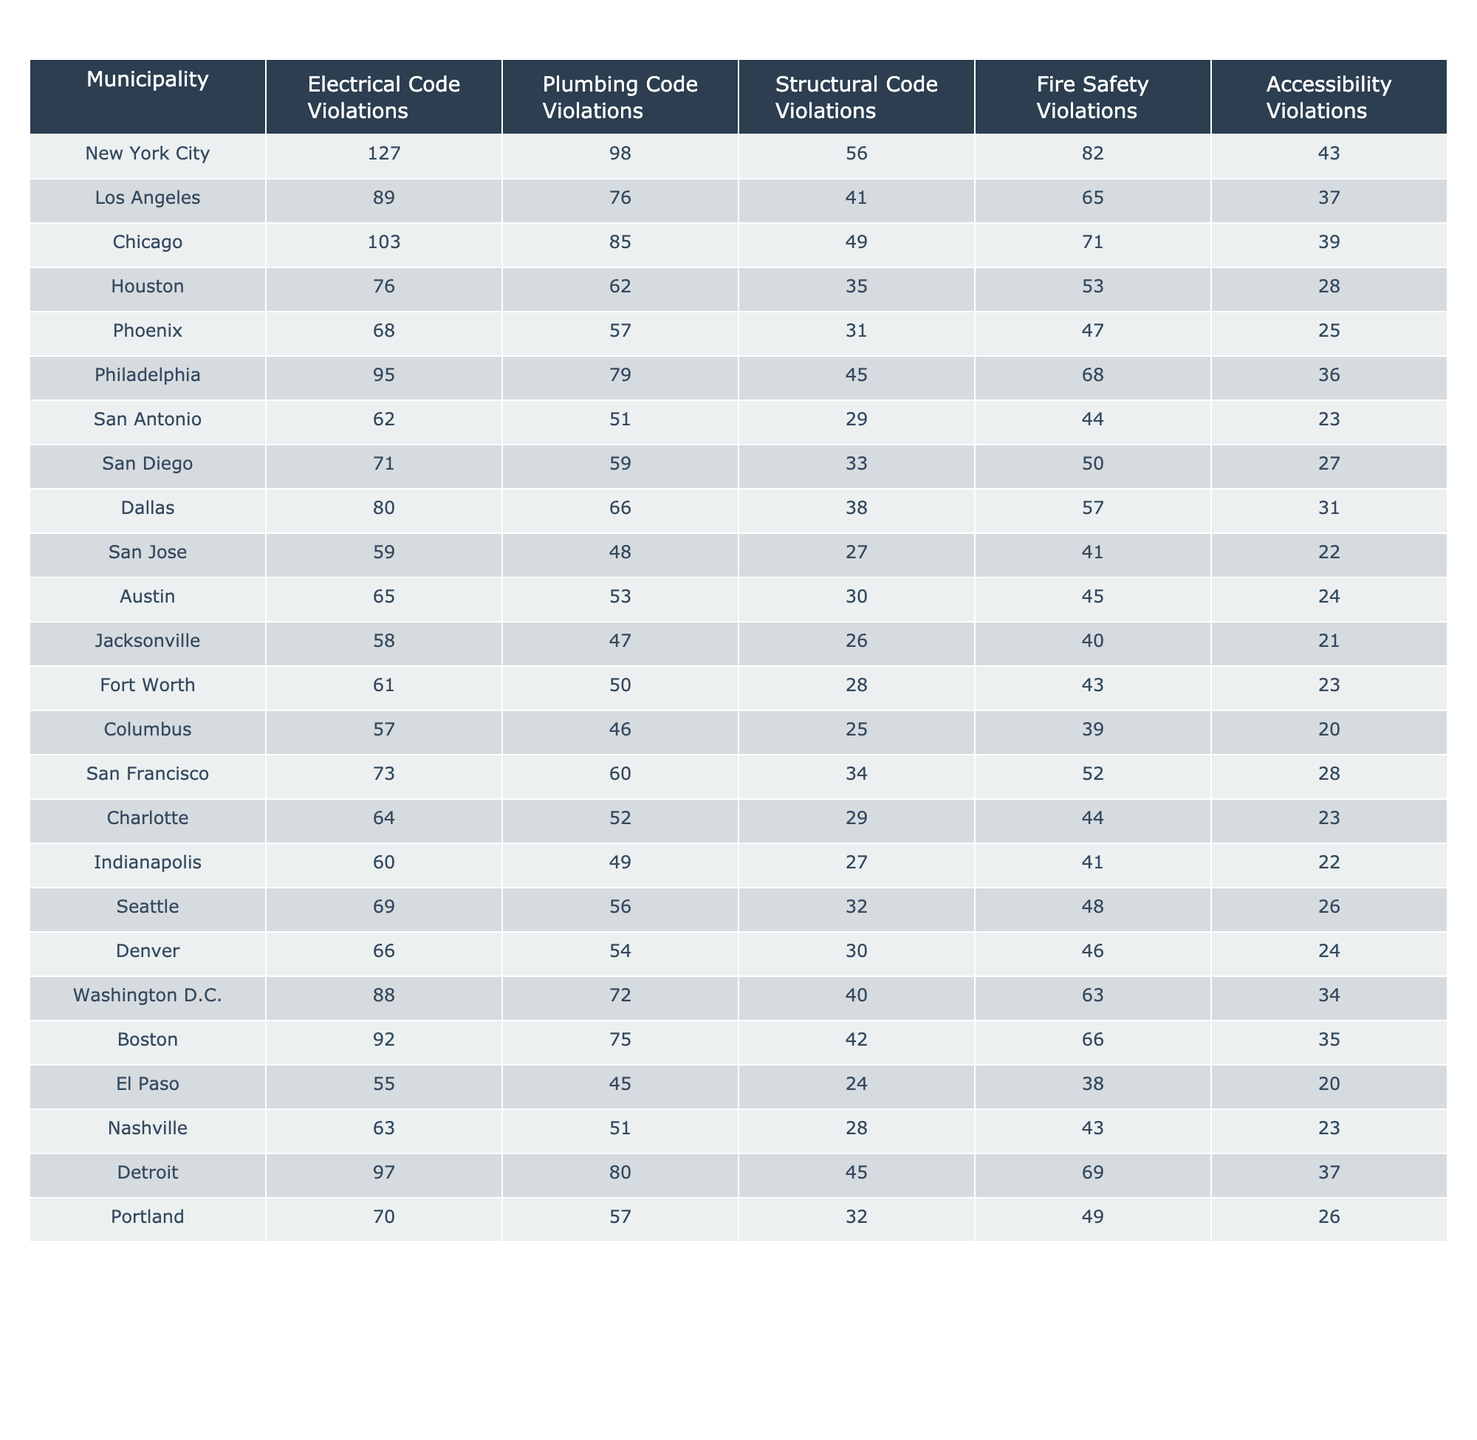What municipality has the highest number of Electrical Code Violations? By looking at the first column in the table, New York City has 127 Electrical Code Violations, which is higher than any other municipality listed.
Answer: New York City What is the total number of Structural Code Violations across all municipalities? To find the total, I sum the Structural Code Violations: 56 + 41 + 49 + 35 + 31 + 45 + 29 + 33 + 38 + 27 + 30 + 26 + 28 + 25 + 34 + 29 + 27 + 32 + 30 + 40 + 42 + 24 + 28 + 45 + 32 = 694.
Answer: 694 Which municipality has the least number of Plumbing Code Violations? San Antonio has the least number of Plumbing Code Violations, with a total of 51. This can be determined by comparing the values in the Plumbing Code Violations column and finding the lowest.
Answer: San Antonio Are there more Electrical Code Violations in Chicago than in Houston? Chicago has 103 Electrical Code Violations while Houston has 76. Therefore, Chicago has more violations than Houston.
Answer: Yes What is the average number of Fire Safety Violations across all municipalities? To calculate the average, I sum all Fire Safety Violations (82 + 65 + 71 + 53 + 47 + 68 + 44 + 50 + 57 + 41 + 45 + 40 + 43 + 39 + 52 + 44 + 41 + 48 + 46 + 63 + 66 + 38 + 43 + 69 + 49 = 998) and divide by the number of municipalities (25). So the average is 998 / 25 = 39.92.
Answer: 39.92 Which municipalities have more than 80 Accessibility Violations? A review of the Accessibility Violations column shows that New York City (43), Chicago (39), Philadelphia (36), and the rest have fewer than or equal to 36 violations, meaning no municipalities have more than 80 Accessibility Violations.
Answer: None What is the difference in the number of Plumbing Code Violations between Los Angeles and Philadelphia? Los Angeles has 76 Plumbing Code Violations while Philadelphia has 79. The difference is calculated by subtracting Los Angeles' violations from Philadelphia's (79 - 76 = 3).
Answer: 3 Is the number of Fire Safety Violations in Dallas greater than the average of all municipalities? The average Fire Safety Violations across all municipalities is calculated to be 39.92, while Dallas has 57 Fire Safety Violations. Since 57 is greater than 39.92, the answer is yes.
Answer: Yes How many municipalities have more Fire Safety Violations than Structural Code Violations? By comparing each municipality's Fire Safety and Structural Code Violations, I find that the following have more Fire Safety Violations than Structural Code Violations: New York City, Chicago, Philadelphia, Dallas, San Francisco, and Washington D.C. This totals 6 municipalities.
Answer: 6 Which municipality has the least number of total code violations across all categories? To find the municipality with the least code violations, I sum all violations for each municipality and compare them. San Antonio has the total of (62 + 51 + 29 + 44 + 23 = 209), which is the lowest compared to others.
Answer: San Antonio 